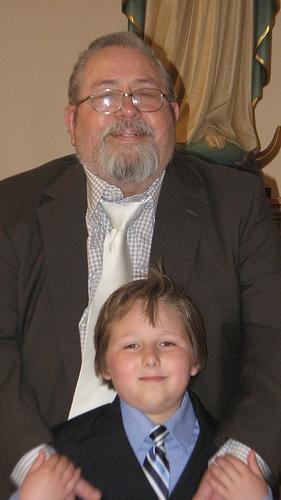How many people are in the photo?
Give a very brief answer. 2. How many train cars are under the poles?
Give a very brief answer. 0. 